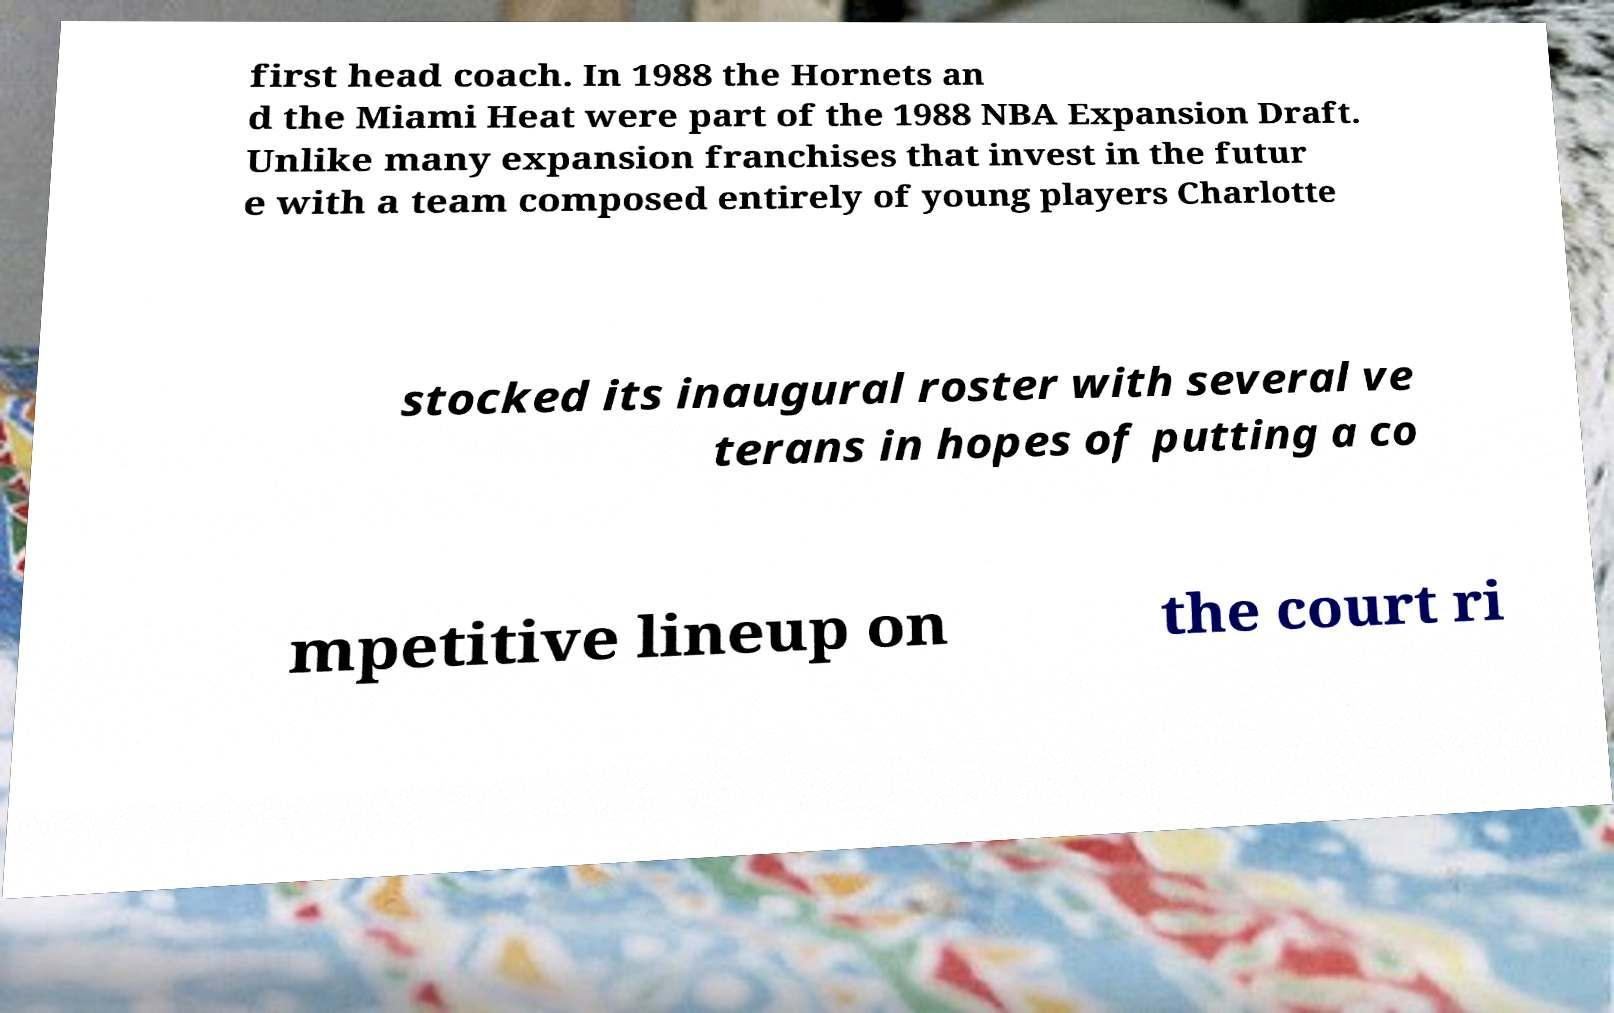Please identify and transcribe the text found in this image. first head coach. In 1988 the Hornets an d the Miami Heat were part of the 1988 NBA Expansion Draft. Unlike many expansion franchises that invest in the futur e with a team composed entirely of young players Charlotte stocked its inaugural roster with several ve terans in hopes of putting a co mpetitive lineup on the court ri 